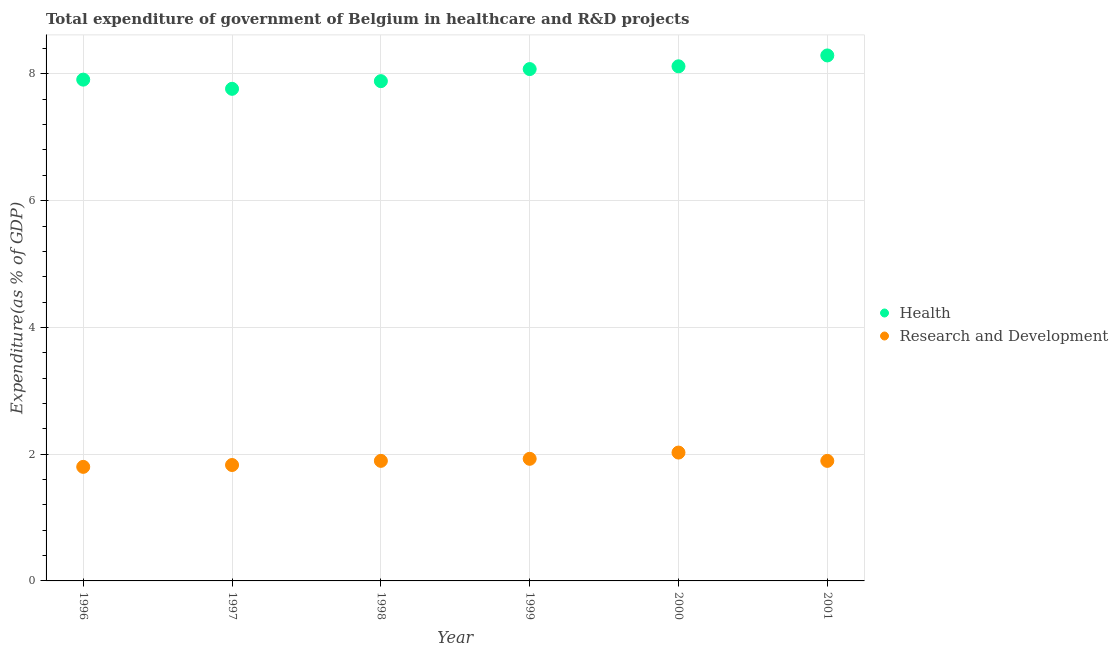What is the expenditure in r&d in 1998?
Your answer should be very brief. 1.89. Across all years, what is the maximum expenditure in r&d?
Make the answer very short. 2.03. Across all years, what is the minimum expenditure in healthcare?
Offer a terse response. 7.77. In which year was the expenditure in r&d minimum?
Offer a very short reply. 1996. What is the total expenditure in r&d in the graph?
Offer a terse response. 11.37. What is the difference between the expenditure in r&d in 1996 and that in 1997?
Keep it short and to the point. -0.03. What is the difference between the expenditure in r&d in 2001 and the expenditure in healthcare in 2000?
Make the answer very short. -6.23. What is the average expenditure in healthcare per year?
Keep it short and to the point. 8.01. In the year 1997, what is the difference between the expenditure in healthcare and expenditure in r&d?
Provide a succinct answer. 5.94. What is the ratio of the expenditure in healthcare in 1996 to that in 1997?
Provide a succinct answer. 1.02. Is the expenditure in healthcare in 1996 less than that in 1999?
Ensure brevity in your answer.  Yes. Is the difference between the expenditure in r&d in 1997 and 2001 greater than the difference between the expenditure in healthcare in 1997 and 2001?
Give a very brief answer. Yes. What is the difference between the highest and the second highest expenditure in healthcare?
Your answer should be compact. 0.17. What is the difference between the highest and the lowest expenditure in healthcare?
Your answer should be compact. 0.53. In how many years, is the expenditure in r&d greater than the average expenditure in r&d taken over all years?
Make the answer very short. 2. Is the sum of the expenditure in healthcare in 1997 and 1999 greater than the maximum expenditure in r&d across all years?
Keep it short and to the point. Yes. Does the expenditure in healthcare monotonically increase over the years?
Make the answer very short. No. Is the expenditure in healthcare strictly greater than the expenditure in r&d over the years?
Your answer should be very brief. Yes. Is the expenditure in healthcare strictly less than the expenditure in r&d over the years?
Provide a short and direct response. No. How many years are there in the graph?
Make the answer very short. 6. What is the difference between two consecutive major ticks on the Y-axis?
Provide a succinct answer. 2. Are the values on the major ticks of Y-axis written in scientific E-notation?
Provide a short and direct response. No. Does the graph contain any zero values?
Ensure brevity in your answer.  No. Does the graph contain grids?
Provide a short and direct response. Yes. How many legend labels are there?
Your answer should be compact. 2. What is the title of the graph?
Your answer should be compact. Total expenditure of government of Belgium in healthcare and R&D projects. Does "Mobile cellular" appear as one of the legend labels in the graph?
Make the answer very short. No. What is the label or title of the X-axis?
Give a very brief answer. Year. What is the label or title of the Y-axis?
Keep it short and to the point. Expenditure(as % of GDP). What is the Expenditure(as % of GDP) in Health in 1996?
Offer a terse response. 7.91. What is the Expenditure(as % of GDP) in Research and Development in 1996?
Provide a short and direct response. 1.8. What is the Expenditure(as % of GDP) of Health in 1997?
Provide a short and direct response. 7.77. What is the Expenditure(as % of GDP) in Research and Development in 1997?
Your answer should be compact. 1.83. What is the Expenditure(as % of GDP) of Health in 1998?
Provide a short and direct response. 7.89. What is the Expenditure(as % of GDP) in Research and Development in 1998?
Ensure brevity in your answer.  1.89. What is the Expenditure(as % of GDP) in Health in 1999?
Your answer should be compact. 8.08. What is the Expenditure(as % of GDP) in Research and Development in 1999?
Make the answer very short. 1.93. What is the Expenditure(as % of GDP) in Health in 2000?
Offer a very short reply. 8.12. What is the Expenditure(as % of GDP) of Research and Development in 2000?
Offer a very short reply. 2.03. What is the Expenditure(as % of GDP) of Health in 2001?
Your response must be concise. 8.29. What is the Expenditure(as % of GDP) in Research and Development in 2001?
Provide a succinct answer. 1.89. Across all years, what is the maximum Expenditure(as % of GDP) in Health?
Your answer should be compact. 8.29. Across all years, what is the maximum Expenditure(as % of GDP) in Research and Development?
Your response must be concise. 2.03. Across all years, what is the minimum Expenditure(as % of GDP) in Health?
Keep it short and to the point. 7.77. Across all years, what is the minimum Expenditure(as % of GDP) in Research and Development?
Your answer should be compact. 1.8. What is the total Expenditure(as % of GDP) of Health in the graph?
Offer a very short reply. 48.05. What is the total Expenditure(as % of GDP) in Research and Development in the graph?
Offer a very short reply. 11.37. What is the difference between the Expenditure(as % of GDP) of Health in 1996 and that in 1997?
Ensure brevity in your answer.  0.14. What is the difference between the Expenditure(as % of GDP) in Research and Development in 1996 and that in 1997?
Your answer should be very brief. -0.03. What is the difference between the Expenditure(as % of GDP) of Health in 1996 and that in 1998?
Provide a succinct answer. 0.02. What is the difference between the Expenditure(as % of GDP) in Research and Development in 1996 and that in 1998?
Ensure brevity in your answer.  -0.09. What is the difference between the Expenditure(as % of GDP) in Health in 1996 and that in 1999?
Make the answer very short. -0.17. What is the difference between the Expenditure(as % of GDP) of Research and Development in 1996 and that in 1999?
Give a very brief answer. -0.13. What is the difference between the Expenditure(as % of GDP) in Health in 1996 and that in 2000?
Offer a terse response. -0.21. What is the difference between the Expenditure(as % of GDP) of Research and Development in 1996 and that in 2000?
Make the answer very short. -0.23. What is the difference between the Expenditure(as % of GDP) in Health in 1996 and that in 2001?
Make the answer very short. -0.38. What is the difference between the Expenditure(as % of GDP) of Research and Development in 1996 and that in 2001?
Offer a very short reply. -0.09. What is the difference between the Expenditure(as % of GDP) of Health in 1997 and that in 1998?
Your answer should be very brief. -0.12. What is the difference between the Expenditure(as % of GDP) in Research and Development in 1997 and that in 1998?
Ensure brevity in your answer.  -0.07. What is the difference between the Expenditure(as % of GDP) of Health in 1997 and that in 1999?
Offer a terse response. -0.31. What is the difference between the Expenditure(as % of GDP) of Research and Development in 1997 and that in 1999?
Offer a terse response. -0.1. What is the difference between the Expenditure(as % of GDP) of Health in 1997 and that in 2000?
Ensure brevity in your answer.  -0.36. What is the difference between the Expenditure(as % of GDP) of Research and Development in 1997 and that in 2000?
Your answer should be very brief. -0.2. What is the difference between the Expenditure(as % of GDP) of Health in 1997 and that in 2001?
Give a very brief answer. -0.53. What is the difference between the Expenditure(as % of GDP) in Research and Development in 1997 and that in 2001?
Provide a succinct answer. -0.07. What is the difference between the Expenditure(as % of GDP) of Health in 1998 and that in 1999?
Offer a very short reply. -0.19. What is the difference between the Expenditure(as % of GDP) of Research and Development in 1998 and that in 1999?
Provide a succinct answer. -0.03. What is the difference between the Expenditure(as % of GDP) of Health in 1998 and that in 2000?
Give a very brief answer. -0.23. What is the difference between the Expenditure(as % of GDP) in Research and Development in 1998 and that in 2000?
Your answer should be compact. -0.13. What is the difference between the Expenditure(as % of GDP) of Health in 1998 and that in 2001?
Your answer should be compact. -0.41. What is the difference between the Expenditure(as % of GDP) of Research and Development in 1998 and that in 2001?
Ensure brevity in your answer.  0. What is the difference between the Expenditure(as % of GDP) of Health in 1999 and that in 2000?
Provide a succinct answer. -0.04. What is the difference between the Expenditure(as % of GDP) of Research and Development in 1999 and that in 2000?
Your response must be concise. -0.1. What is the difference between the Expenditure(as % of GDP) in Health in 1999 and that in 2001?
Keep it short and to the point. -0.22. What is the difference between the Expenditure(as % of GDP) in Research and Development in 1999 and that in 2001?
Offer a terse response. 0.03. What is the difference between the Expenditure(as % of GDP) of Health in 2000 and that in 2001?
Provide a short and direct response. -0.17. What is the difference between the Expenditure(as % of GDP) in Research and Development in 2000 and that in 2001?
Keep it short and to the point. 0.13. What is the difference between the Expenditure(as % of GDP) in Health in 1996 and the Expenditure(as % of GDP) in Research and Development in 1997?
Keep it short and to the point. 6.08. What is the difference between the Expenditure(as % of GDP) of Health in 1996 and the Expenditure(as % of GDP) of Research and Development in 1998?
Your answer should be compact. 6.02. What is the difference between the Expenditure(as % of GDP) in Health in 1996 and the Expenditure(as % of GDP) in Research and Development in 1999?
Offer a terse response. 5.98. What is the difference between the Expenditure(as % of GDP) in Health in 1996 and the Expenditure(as % of GDP) in Research and Development in 2000?
Offer a very short reply. 5.88. What is the difference between the Expenditure(as % of GDP) in Health in 1996 and the Expenditure(as % of GDP) in Research and Development in 2001?
Offer a very short reply. 6.02. What is the difference between the Expenditure(as % of GDP) in Health in 1997 and the Expenditure(as % of GDP) in Research and Development in 1998?
Offer a terse response. 5.87. What is the difference between the Expenditure(as % of GDP) in Health in 1997 and the Expenditure(as % of GDP) in Research and Development in 1999?
Provide a succinct answer. 5.84. What is the difference between the Expenditure(as % of GDP) in Health in 1997 and the Expenditure(as % of GDP) in Research and Development in 2000?
Give a very brief answer. 5.74. What is the difference between the Expenditure(as % of GDP) in Health in 1997 and the Expenditure(as % of GDP) in Research and Development in 2001?
Ensure brevity in your answer.  5.87. What is the difference between the Expenditure(as % of GDP) of Health in 1998 and the Expenditure(as % of GDP) of Research and Development in 1999?
Your answer should be compact. 5.96. What is the difference between the Expenditure(as % of GDP) of Health in 1998 and the Expenditure(as % of GDP) of Research and Development in 2000?
Provide a succinct answer. 5.86. What is the difference between the Expenditure(as % of GDP) in Health in 1998 and the Expenditure(as % of GDP) in Research and Development in 2001?
Your response must be concise. 5.99. What is the difference between the Expenditure(as % of GDP) of Health in 1999 and the Expenditure(as % of GDP) of Research and Development in 2000?
Offer a very short reply. 6.05. What is the difference between the Expenditure(as % of GDP) in Health in 1999 and the Expenditure(as % of GDP) in Research and Development in 2001?
Offer a very short reply. 6.18. What is the difference between the Expenditure(as % of GDP) of Health in 2000 and the Expenditure(as % of GDP) of Research and Development in 2001?
Make the answer very short. 6.23. What is the average Expenditure(as % of GDP) in Health per year?
Offer a terse response. 8.01. What is the average Expenditure(as % of GDP) in Research and Development per year?
Offer a terse response. 1.9. In the year 1996, what is the difference between the Expenditure(as % of GDP) of Health and Expenditure(as % of GDP) of Research and Development?
Your response must be concise. 6.11. In the year 1997, what is the difference between the Expenditure(as % of GDP) of Health and Expenditure(as % of GDP) of Research and Development?
Make the answer very short. 5.94. In the year 1998, what is the difference between the Expenditure(as % of GDP) in Health and Expenditure(as % of GDP) in Research and Development?
Your answer should be very brief. 5.99. In the year 1999, what is the difference between the Expenditure(as % of GDP) in Health and Expenditure(as % of GDP) in Research and Development?
Provide a succinct answer. 6.15. In the year 2000, what is the difference between the Expenditure(as % of GDP) in Health and Expenditure(as % of GDP) in Research and Development?
Offer a terse response. 6.1. In the year 2001, what is the difference between the Expenditure(as % of GDP) in Health and Expenditure(as % of GDP) in Research and Development?
Offer a terse response. 6.4. What is the ratio of the Expenditure(as % of GDP) in Health in 1996 to that in 1997?
Give a very brief answer. 1.02. What is the ratio of the Expenditure(as % of GDP) of Research and Development in 1996 to that in 1997?
Provide a succinct answer. 0.98. What is the ratio of the Expenditure(as % of GDP) of Health in 1996 to that in 1999?
Provide a succinct answer. 0.98. What is the ratio of the Expenditure(as % of GDP) in Research and Development in 1996 to that in 1999?
Your answer should be compact. 0.93. What is the ratio of the Expenditure(as % of GDP) of Health in 1996 to that in 2000?
Offer a terse response. 0.97. What is the ratio of the Expenditure(as % of GDP) in Research and Development in 1996 to that in 2000?
Provide a short and direct response. 0.89. What is the ratio of the Expenditure(as % of GDP) in Health in 1996 to that in 2001?
Your answer should be very brief. 0.95. What is the ratio of the Expenditure(as % of GDP) in Research and Development in 1996 to that in 2001?
Your answer should be compact. 0.95. What is the ratio of the Expenditure(as % of GDP) of Health in 1997 to that in 1998?
Your response must be concise. 0.98. What is the ratio of the Expenditure(as % of GDP) in Research and Development in 1997 to that in 1998?
Make the answer very short. 0.97. What is the ratio of the Expenditure(as % of GDP) in Health in 1997 to that in 1999?
Your answer should be compact. 0.96. What is the ratio of the Expenditure(as % of GDP) in Research and Development in 1997 to that in 1999?
Your answer should be very brief. 0.95. What is the ratio of the Expenditure(as % of GDP) in Health in 1997 to that in 2000?
Keep it short and to the point. 0.96. What is the ratio of the Expenditure(as % of GDP) of Research and Development in 1997 to that in 2000?
Make the answer very short. 0.9. What is the ratio of the Expenditure(as % of GDP) in Health in 1997 to that in 2001?
Make the answer very short. 0.94. What is the ratio of the Expenditure(as % of GDP) in Research and Development in 1997 to that in 2001?
Provide a short and direct response. 0.97. What is the ratio of the Expenditure(as % of GDP) in Health in 1998 to that in 1999?
Offer a very short reply. 0.98. What is the ratio of the Expenditure(as % of GDP) of Research and Development in 1998 to that in 1999?
Your response must be concise. 0.98. What is the ratio of the Expenditure(as % of GDP) of Health in 1998 to that in 2000?
Your response must be concise. 0.97. What is the ratio of the Expenditure(as % of GDP) in Research and Development in 1998 to that in 2000?
Offer a terse response. 0.94. What is the ratio of the Expenditure(as % of GDP) in Health in 1998 to that in 2001?
Offer a very short reply. 0.95. What is the ratio of the Expenditure(as % of GDP) in Research and Development in 1998 to that in 2001?
Ensure brevity in your answer.  1. What is the ratio of the Expenditure(as % of GDP) in Research and Development in 1999 to that in 2000?
Your answer should be compact. 0.95. What is the ratio of the Expenditure(as % of GDP) of Health in 1999 to that in 2001?
Provide a short and direct response. 0.97. What is the ratio of the Expenditure(as % of GDP) in Research and Development in 1999 to that in 2001?
Give a very brief answer. 1.02. What is the ratio of the Expenditure(as % of GDP) of Health in 2000 to that in 2001?
Keep it short and to the point. 0.98. What is the ratio of the Expenditure(as % of GDP) in Research and Development in 2000 to that in 2001?
Give a very brief answer. 1.07. What is the difference between the highest and the second highest Expenditure(as % of GDP) of Health?
Your answer should be very brief. 0.17. What is the difference between the highest and the second highest Expenditure(as % of GDP) in Research and Development?
Give a very brief answer. 0.1. What is the difference between the highest and the lowest Expenditure(as % of GDP) in Health?
Offer a terse response. 0.53. What is the difference between the highest and the lowest Expenditure(as % of GDP) of Research and Development?
Your response must be concise. 0.23. 